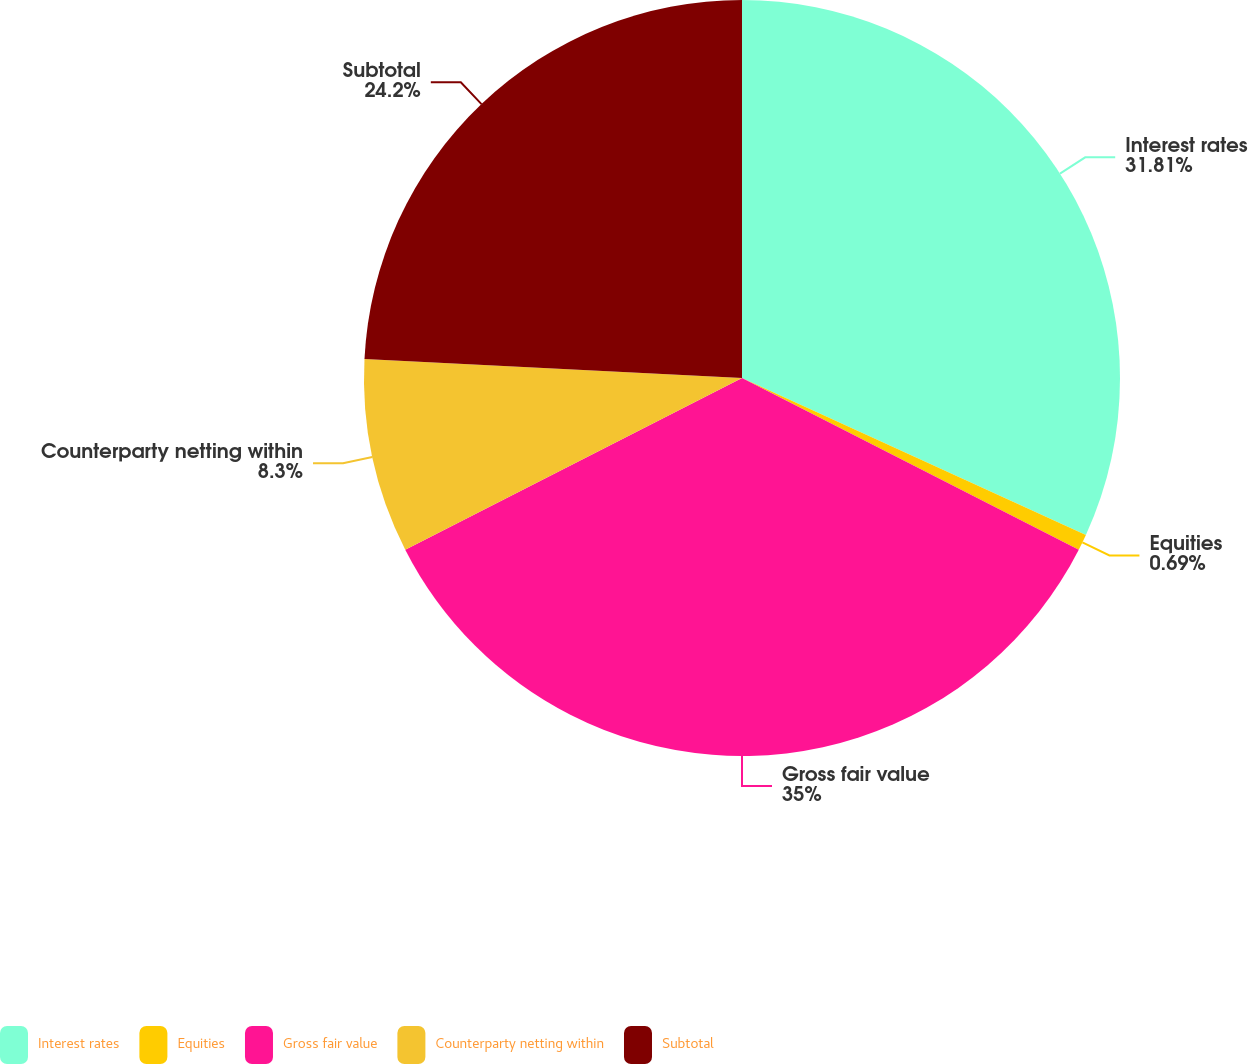Convert chart. <chart><loc_0><loc_0><loc_500><loc_500><pie_chart><fcel>Interest rates<fcel>Equities<fcel>Gross fair value<fcel>Counterparty netting within<fcel>Subtotal<nl><fcel>31.81%<fcel>0.69%<fcel>34.99%<fcel>8.3%<fcel>24.2%<nl></chart> 